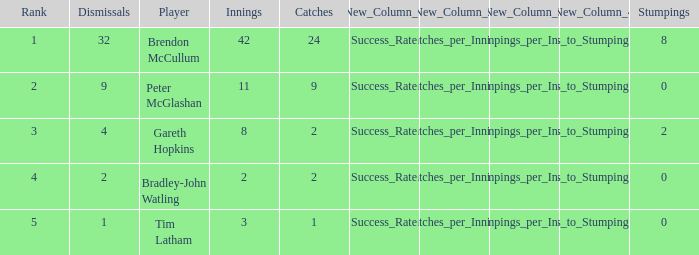How many dismissals did the player Peter McGlashan have? 9.0. 